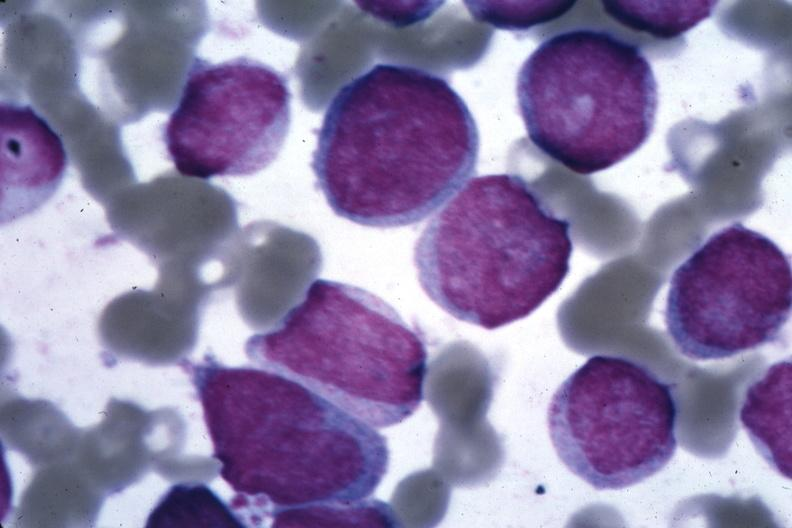s acute myelogenous leukemia present?
Answer the question using a single word or phrase. Yes 